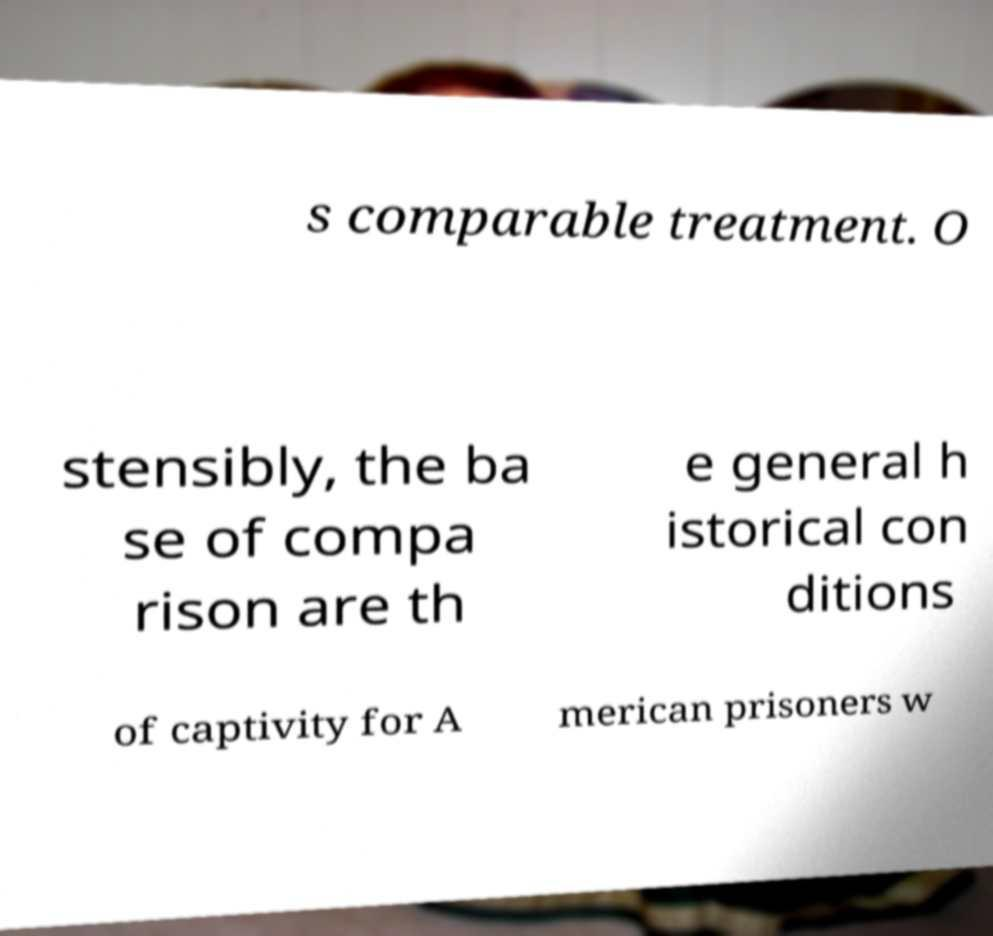Could you assist in decoding the text presented in this image and type it out clearly? s comparable treatment. O stensibly, the ba se of compa rison are th e general h istorical con ditions of captivity for A merican prisoners w 